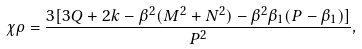Convert formula to latex. <formula><loc_0><loc_0><loc_500><loc_500>\chi \rho = \frac { 3 [ 3 Q + 2 k - \beta ^ { 2 } ( M ^ { 2 } + N ^ { 2 } ) - \beta ^ { 2 } \beta _ { 1 } ( P - \beta _ { 1 } ) ] } { P ^ { 2 } } ,</formula> 